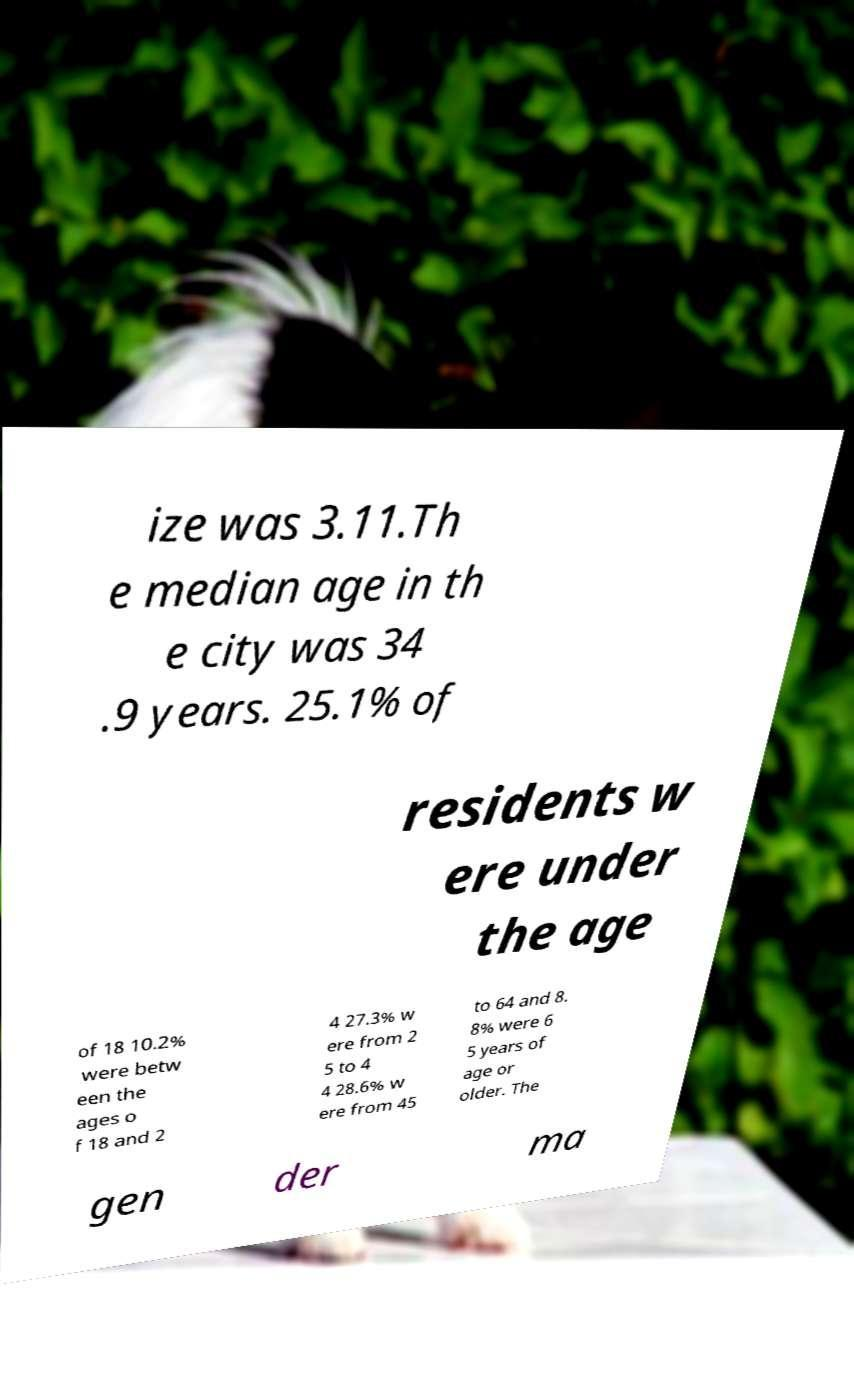Could you extract and type out the text from this image? ize was 3.11.Th e median age in th e city was 34 .9 years. 25.1% of residents w ere under the age of 18 10.2% were betw een the ages o f 18 and 2 4 27.3% w ere from 2 5 to 4 4 28.6% w ere from 45 to 64 and 8. 8% were 6 5 years of age or older. The gen der ma 